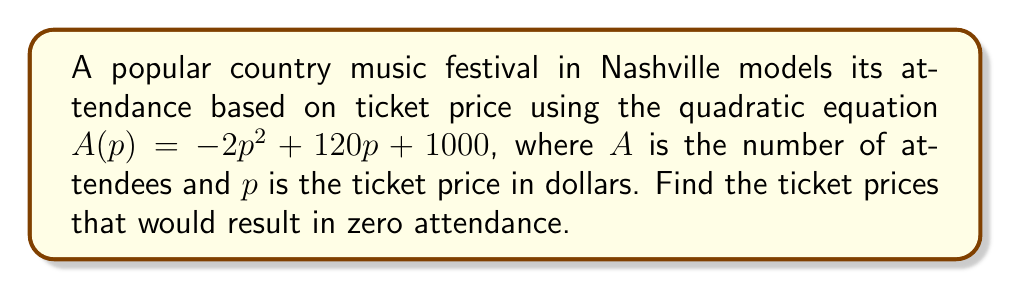Give your solution to this math problem. To find the ticket prices that result in zero attendance, we need to solve the equation $A(p) = 0$:

1) Set up the equation:
   $-2p^2 + 120p + 1000 = 0$

2) This is a quadratic equation in the standard form $ax^2 + bx + c = 0$, where:
   $a = -2$, $b = 120$, and $c = 1000$

3) We can solve this using the quadratic formula: $x = \frac{-b \pm \sqrt{b^2 - 4ac}}{2a}$

4) Substituting our values:
   $p = \frac{-120 \pm \sqrt{120^2 - 4(-2)(1000)}}{2(-2)}$

5) Simplify under the square root:
   $p = \frac{-120 \pm \sqrt{14400 + 8000}}{-4} = \frac{-120 \pm \sqrt{22400}}{-4}$

6) Simplify the square root:
   $p = \frac{-120 \pm 150}{-4}$

7) This gives us two solutions:
   $p = \frac{-120 + 150}{-4} = \frac{30}{-4} = -7.5$
   $p = \frac{-120 - 150}{-4} = \frac{-270}{-4} = 67.5$

8) However, since ticket prices can't be negative, we discard the negative solution.

Therefore, the only valid solution is a ticket price of $67.50.
Answer: $67.50 